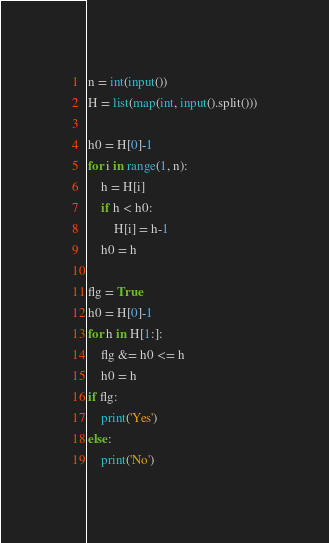Convert code to text. <code><loc_0><loc_0><loc_500><loc_500><_Python_>n = int(input())
H = list(map(int, input().split()))

h0 = H[0]-1
for i in range(1, n):
    h = H[i]
    if h < h0:
        H[i] = h-1
    h0 = h

flg = True
h0 = H[0]-1
for h in H[1:]:
    flg &= h0 <= h
    h0 = h
if flg:
    print('Yes')
else:
    print('No')</code> 